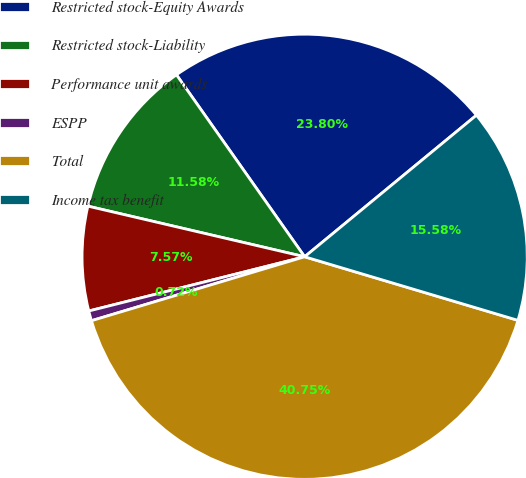Convert chart to OTSL. <chart><loc_0><loc_0><loc_500><loc_500><pie_chart><fcel>Restricted stock-Equity Awards<fcel>Restricted stock-Liability<fcel>Performance unit awards<fcel>ESPP<fcel>Total<fcel>Income tax benefit<nl><fcel>23.8%<fcel>11.58%<fcel>7.57%<fcel>0.72%<fcel>40.75%<fcel>15.58%<nl></chart> 